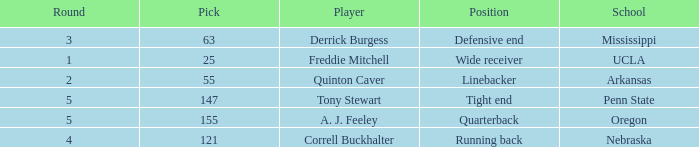Who was the player who was pick number 147? Tony Stewart. 